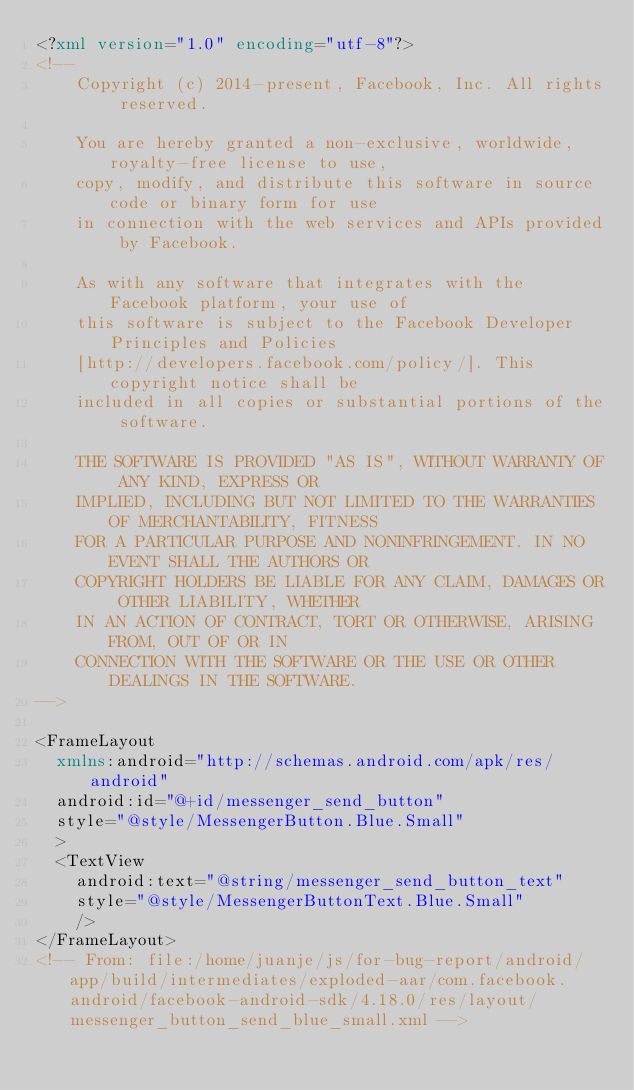Convert code to text. <code><loc_0><loc_0><loc_500><loc_500><_XML_><?xml version="1.0" encoding="utf-8"?>
<!--
    Copyright (c) 2014-present, Facebook, Inc. All rights reserved.

    You are hereby granted a non-exclusive, worldwide, royalty-free license to use,
    copy, modify, and distribute this software in source code or binary form for use
    in connection with the web services and APIs provided by Facebook.

    As with any software that integrates with the Facebook platform, your use of
    this software is subject to the Facebook Developer Principles and Policies
    [http://developers.facebook.com/policy/]. This copyright notice shall be
    included in all copies or substantial portions of the software.

    THE SOFTWARE IS PROVIDED "AS IS", WITHOUT WARRANTY OF ANY KIND, EXPRESS OR
    IMPLIED, INCLUDING BUT NOT LIMITED TO THE WARRANTIES OF MERCHANTABILITY, FITNESS
    FOR A PARTICULAR PURPOSE AND NONINFRINGEMENT. IN NO EVENT SHALL THE AUTHORS OR
    COPYRIGHT HOLDERS BE LIABLE FOR ANY CLAIM, DAMAGES OR OTHER LIABILITY, WHETHER
    IN AN ACTION OF CONTRACT, TORT OR OTHERWISE, ARISING FROM, OUT OF OR IN
    CONNECTION WITH THE SOFTWARE OR THE USE OR OTHER DEALINGS IN THE SOFTWARE.
-->

<FrameLayout
  xmlns:android="http://schemas.android.com/apk/res/android"
  android:id="@+id/messenger_send_button"
  style="@style/MessengerButton.Blue.Small"
  >
  <TextView
    android:text="@string/messenger_send_button_text"
    style="@style/MessengerButtonText.Blue.Small"
    />
</FrameLayout>
<!-- From: file:/home/juanje/js/for-bug-report/android/app/build/intermediates/exploded-aar/com.facebook.android/facebook-android-sdk/4.18.0/res/layout/messenger_button_send_blue_small.xml --></code> 